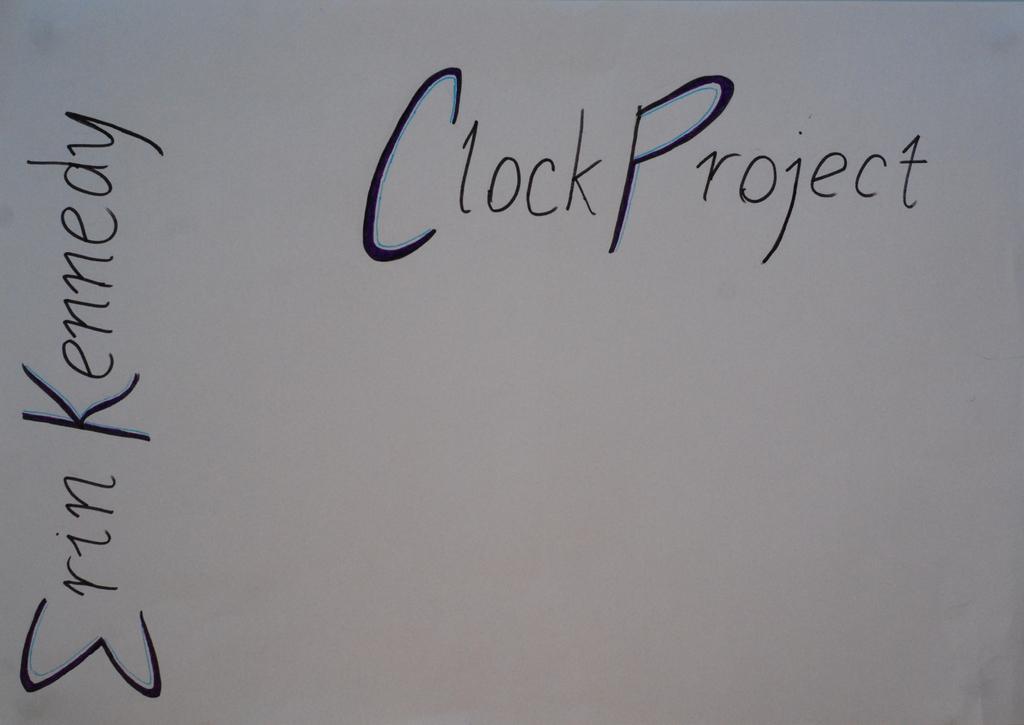How would you summarize this image in a sentence or two? In this image we can see text on the paper. 